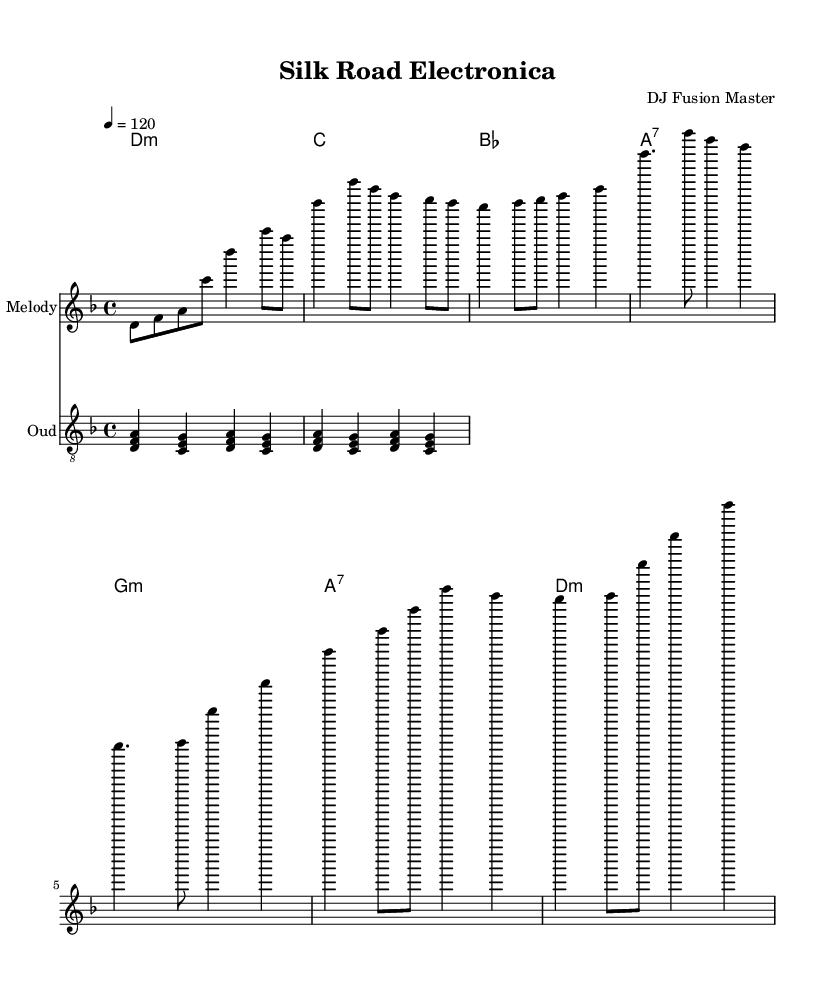What is the key signature of this music? The key signature is D minor, which has one flat (B flat). This can be determined by checking the key signature that is indicated at the beginning of the staff, which is visually represented by a flat sign on the B line.
Answer: D minor What is the time signature of this music? The time signature is 4/4, which is indicated at the beginning of the staff. It means there are four beats in each measure, and each beat is the equivalent of a quarter note. This can be seen right next to the clef sign.
Answer: 4/4 What is the tempo of this piece? The tempo marking is 120, which is indicated above the staff. This is the speed at which the music should be played, specifying 120 beats per minute. The tempo is indicated with the word "tempo" followed by the number.
Answer: 120 How many measures are in the chorus section? The chorus section contains 2 measures. This can be identified by locating the section labeled as "Chorus," then counting the number of measures within that section. In this case, there are two clearly defined measures.
Answer: 2 What is the name of the instrument used for the oud part? The instrument used for the oud part is labeled as "Oud." This is stated in the staff name, which clearly shows the type of instrument being played.
Answer: Oud What type of harmony is primarily used throughout the piece? The harmony primarily used is minor. This is deduced by looking at the chord progression where the chords such as D minor and G minor are prominently featured indicating a minor tonality throughout the piece.
Answer: Minor How many different chords are used in the harmony section? There are 7 different chords used in the harmony section, as listed in the chord names, each representing a different chord shape or tonality appearing in the piece.
Answer: 7 